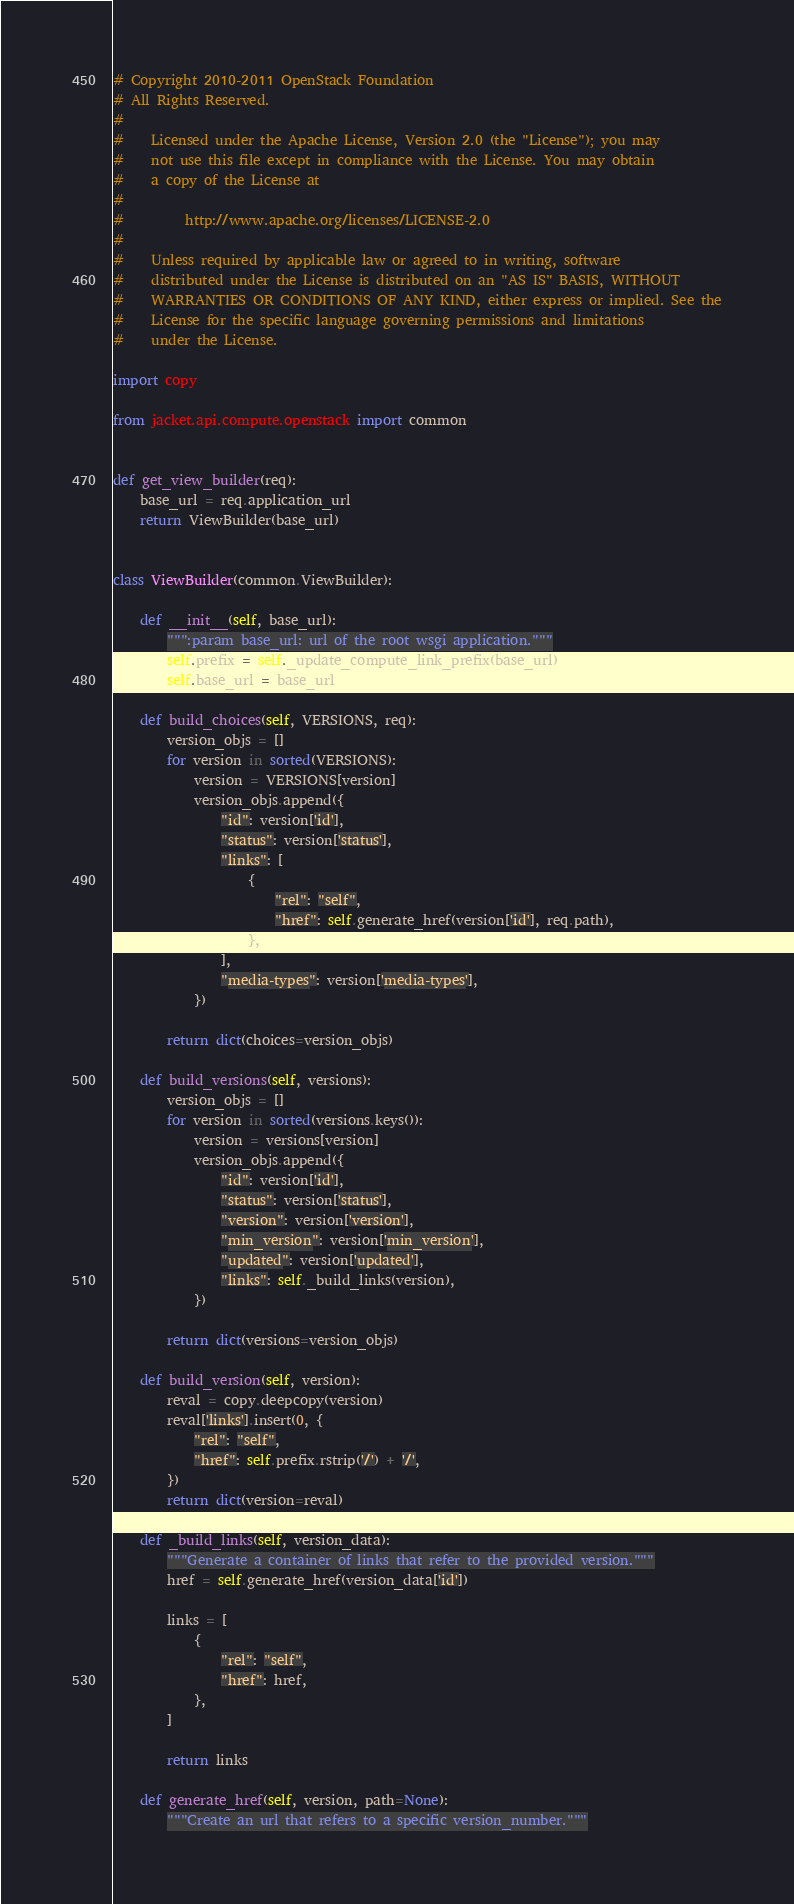<code> <loc_0><loc_0><loc_500><loc_500><_Python_># Copyright 2010-2011 OpenStack Foundation
# All Rights Reserved.
#
#    Licensed under the Apache License, Version 2.0 (the "License"); you may
#    not use this file except in compliance with the License. You may obtain
#    a copy of the License at
#
#         http://www.apache.org/licenses/LICENSE-2.0
#
#    Unless required by applicable law or agreed to in writing, software
#    distributed under the License is distributed on an "AS IS" BASIS, WITHOUT
#    WARRANTIES OR CONDITIONS OF ANY KIND, either express or implied. See the
#    License for the specific language governing permissions and limitations
#    under the License.

import copy

from jacket.api.compute.openstack import common


def get_view_builder(req):
    base_url = req.application_url
    return ViewBuilder(base_url)


class ViewBuilder(common.ViewBuilder):

    def __init__(self, base_url):
        """:param base_url: url of the root wsgi application."""
        self.prefix = self._update_compute_link_prefix(base_url)
        self.base_url = base_url

    def build_choices(self, VERSIONS, req):
        version_objs = []
        for version in sorted(VERSIONS):
            version = VERSIONS[version]
            version_objs.append({
                "id": version['id'],
                "status": version['status'],
                "links": [
                    {
                        "rel": "self",
                        "href": self.generate_href(version['id'], req.path),
                    },
                ],
                "media-types": version['media-types'],
            })

        return dict(choices=version_objs)

    def build_versions(self, versions):
        version_objs = []
        for version in sorted(versions.keys()):
            version = versions[version]
            version_objs.append({
                "id": version['id'],
                "status": version['status'],
                "version": version['version'],
                "min_version": version['min_version'],
                "updated": version['updated'],
                "links": self._build_links(version),
            })

        return dict(versions=version_objs)

    def build_version(self, version):
        reval = copy.deepcopy(version)
        reval['links'].insert(0, {
            "rel": "self",
            "href": self.prefix.rstrip('/') + '/',
        })
        return dict(version=reval)

    def _build_links(self, version_data):
        """Generate a container of links that refer to the provided version."""
        href = self.generate_href(version_data['id'])

        links = [
            {
                "rel": "self",
                "href": href,
            },
        ]

        return links

    def generate_href(self, version, path=None):
        """Create an url that refers to a specific version_number."""</code> 